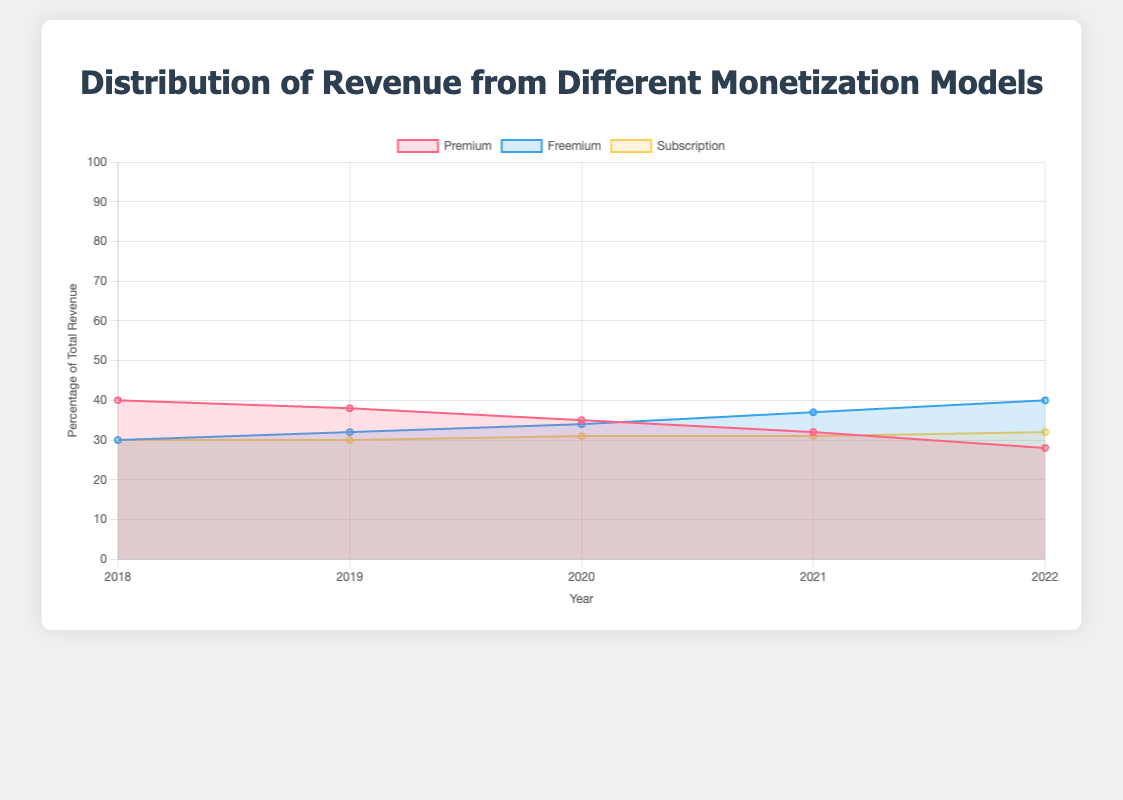What are the three different monetization models depicted in the chart? The models are listed in the legend of the chart. They are "Premium," "Freemium," and "Subscription."
Answer: Premium, Freemium, Subscription Which monetization model showed the highest percentage of total revenue in 2022? The chart shows that in 2022, the Freemium model has the highest percentage value, reading 40%.
Answer: Freemium How did the revenue percentage for the Premium model change from 2018 to 2022? Observing the chart, the Premium model started at 40% in 2018 and declined to 28% in 2022.
Answer: Decreased by 12 percentage points What was the total revenue for Freemium in 2020? Using the tooltip shown on the figure when hovering over 2020 for Freemium, the total revenue for that year was $8,500.
Answer: $8,500 Compare the total revenues for Premium and Subscription models in 2021. Which one was higher? Using tooltips from the chart, Premium had $8,000 in 2021 while Subscription had $7,750. Therefore, Premium was higher.
Answer: Premium Which monetization model remained the most stable in its revenue percentage from 2018 to 2022? By examining the lines, the Subscription model exhibits the least fluctuation, remaining around 30-32% throughout the years.
Answer: Subscription Calculate the average percentage revenue for the Freemium model over the five years. Add the percentage values for Freemium from 2018 to 2022: 30% + 32% + 34% + 37% + 40% = 173%. Divide by 5 to get the average value: 173% / 5 = 34.6%.
Answer: 34.6% Which two models had an opposite trend over the five years, one increasing while the other decreasing? By comparing the trend lines, Premium is decreasing while Freemium is increasing over the five years.
Answer: Premium and Freemium What is the difference in total revenue between the Freemium model and Premium model in 2022? The chart's tooltips show Freemium at $10,000 and Premium at $7,000 in 2022. The difference is $10,000 - $7,000 = $3,000.
Answer: $3,000 What was the total revenue for all three models combined in 2019? Summing up the revenues for each model in 2019, Premium: $9,500, Freemium: $8,000, Subscription: $7,500. Total is $9,500 + $8,000 + $7,500 = $25,000.
Answer: $25,000 